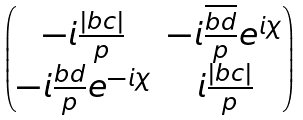Convert formula to latex. <formula><loc_0><loc_0><loc_500><loc_500>\begin{pmatrix} - i \frac { | b c | } { p } & - i \frac { \overline { b } \overline { d } } { p } e ^ { i \chi } \\ - i \frac { b d } { p } e ^ { - i \chi } & i \frac { | b c | } { p } \end{pmatrix}</formula> 